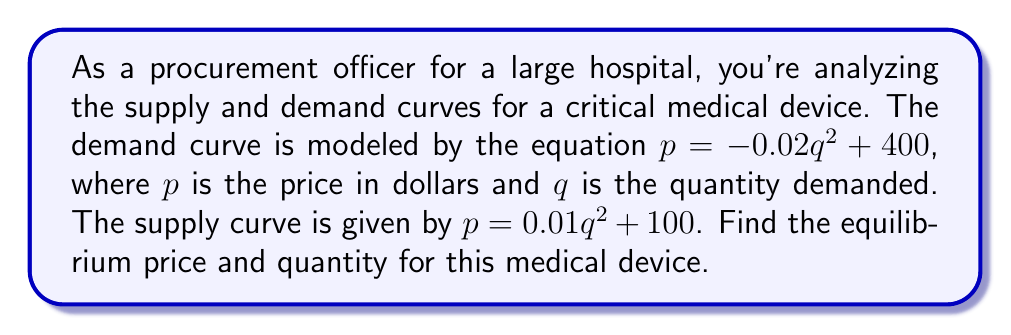Could you help me with this problem? To find the equilibrium price and quantity, we need to find the point where the supply and demand curves intersect. This means we need to solve the equation:

$$-0.02q^2 + 400 = 0.01q^2 + 100$$

Let's solve this step-by-step:

1) First, let's rearrange the equation so that all terms are on one side:
   $$-0.02q^2 + 400 - (0.01q^2 + 100) = 0$$
   $$-0.02q^2 - 0.01q^2 + 300 = 0$$
   $$-0.03q^2 + 300 = 0$$

2) Now we have a quadratic equation in standard form $(aq^2 + bq + c = 0)$:
   $$-0.03q^2 + 300 = 0$$

3) Let's solve for $q$ using the quadratic formula: $q = \frac{-b \pm \sqrt{b^2 - 4ac}}{2a}$
   Here, $a = -0.03$, $b = 0$, and $c = 300$

4) Plugging into the quadratic formula:
   $$q = \frac{0 \pm \sqrt{0^2 - 4(-0.03)(300)}}{2(-0.03)}$$
   $$q = \frac{\pm \sqrt{36}}{-0.06}$$
   $$q = \frac{\pm 6}{-0.06}$$

5) This gives us two solutions:
   $$q = -100 \text{ or } q = 100$$

6) Since quantity cannot be negative, we take the positive solution: $q = 100$

7) To find the equilibrium price, we can plug this quantity into either the demand or supply equation. Let's use the demand equation:

   $$p = -0.02(100)^2 + 400$$
   $$p = -200 + 400 = 200$$

Therefore, the equilibrium quantity is 100 units and the equilibrium price is $200.
Answer: The equilibrium quantity is 100 units and the equilibrium price is $200. 